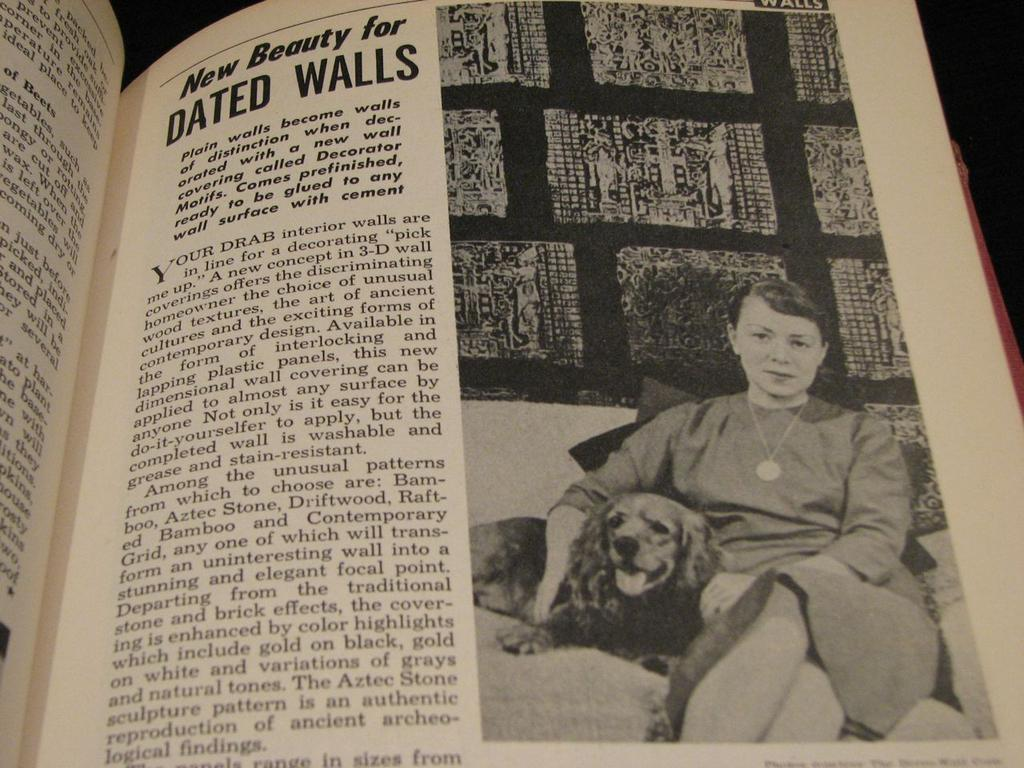What object can be seen in the picture? There is a book in the picture. What is featured on the book? Letters and a photo are printed on the book. What is depicted in the photo on the book? The photo contains a woman sitting on a sofa. What is the woman doing in the photo? The woman is holding a dog in the photo. How many frogs can be seen jumping in the field in the image? There are no frogs or fields present in the image; it features a book with a photo of a woman holding a dog. 